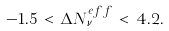Convert formula to latex. <formula><loc_0><loc_0><loc_500><loc_500>- 1 . 5 \, < \, \Delta N ^ { e f f } _ { \nu } \, < \, 4 . 2 .</formula> 